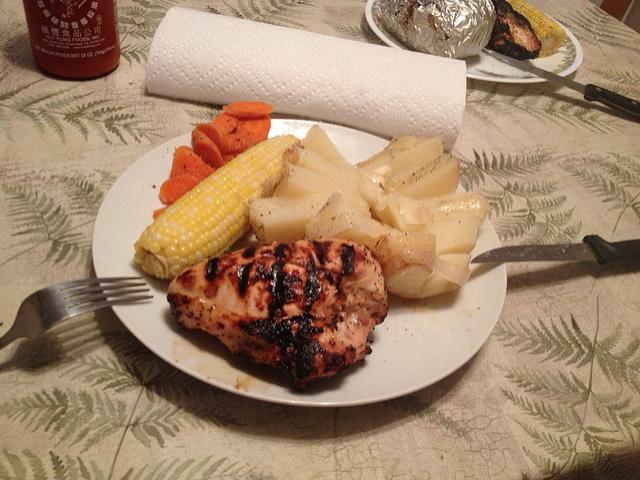What is yellow on the plate?
Concise answer only. Corn. How many different types of vegetables are on the plate?
Short answer required. 3. Is there a meal in the image?
Give a very brief answer. Yes. 